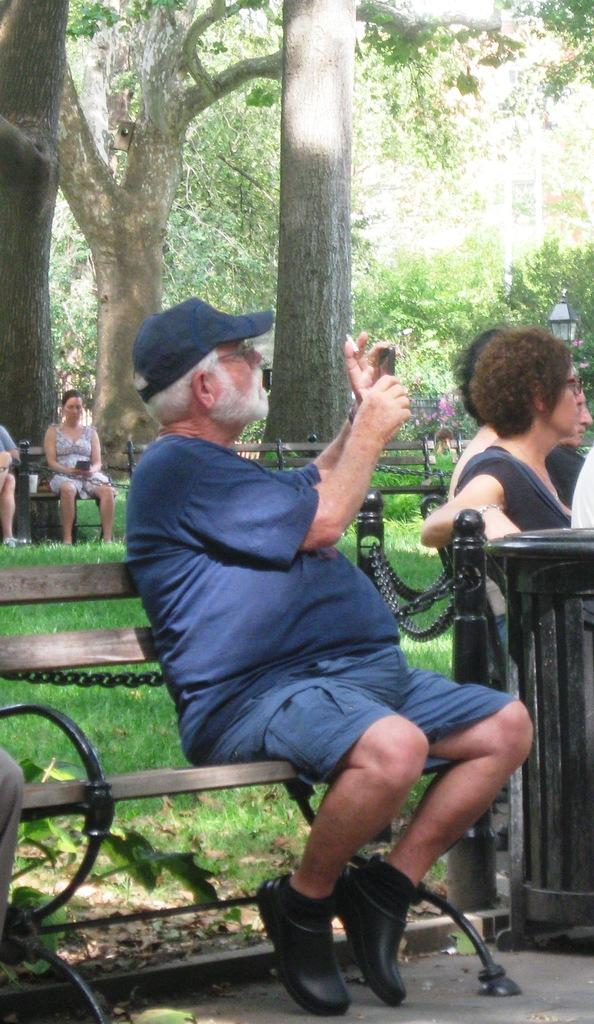What are the people in the image doing? There are persons sitting on a bench in the image. What object is the man holding in the image? The man is holding a phone in the image. What can be seen in the background of the image? Trees and grass are visible in the background of the image. What is the chance of the spark igniting the waste in the image? There is no mention of a spark or waste in the image, so this question cannot be answered. 